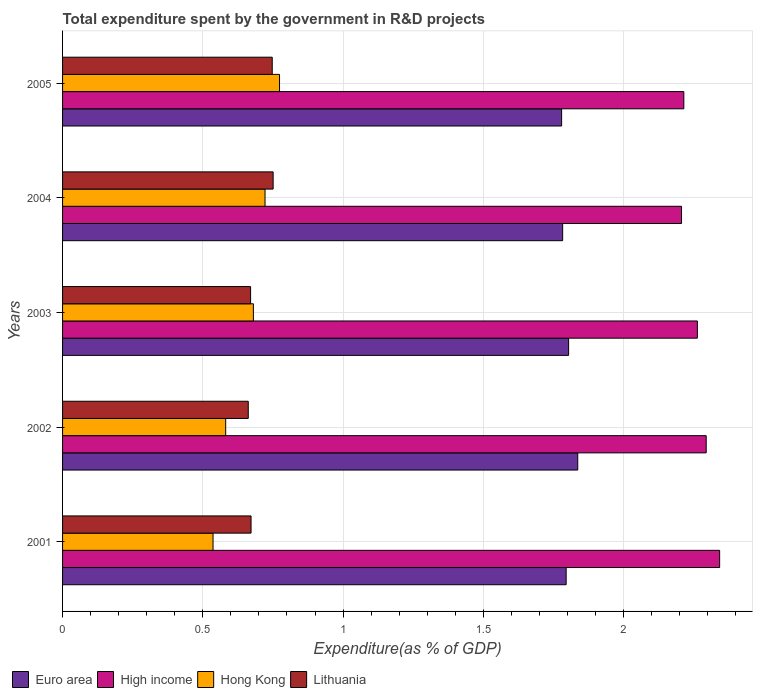How many different coloured bars are there?
Your response must be concise. 4. Are the number of bars per tick equal to the number of legend labels?
Your answer should be compact. Yes. Are the number of bars on each tick of the Y-axis equal?
Offer a very short reply. Yes. What is the total expenditure spent by the government in R&D projects in Hong Kong in 2004?
Provide a short and direct response. 0.72. Across all years, what is the maximum total expenditure spent by the government in R&D projects in Hong Kong?
Your answer should be very brief. 0.77. Across all years, what is the minimum total expenditure spent by the government in R&D projects in High income?
Provide a short and direct response. 2.21. What is the total total expenditure spent by the government in R&D projects in Euro area in the graph?
Provide a short and direct response. 9. What is the difference between the total expenditure spent by the government in R&D projects in Euro area in 2003 and that in 2005?
Keep it short and to the point. 0.02. What is the difference between the total expenditure spent by the government in R&D projects in High income in 2004 and the total expenditure spent by the government in R&D projects in Euro area in 2001?
Offer a very short reply. 0.41. What is the average total expenditure spent by the government in R&D projects in High income per year?
Give a very brief answer. 2.26. In the year 2002, what is the difference between the total expenditure spent by the government in R&D projects in Hong Kong and total expenditure spent by the government in R&D projects in High income?
Your answer should be compact. -1.71. What is the ratio of the total expenditure spent by the government in R&D projects in Hong Kong in 2002 to that in 2005?
Offer a terse response. 0.75. Is the total expenditure spent by the government in R&D projects in Lithuania in 2004 less than that in 2005?
Offer a very short reply. No. What is the difference between the highest and the second highest total expenditure spent by the government in R&D projects in Lithuania?
Ensure brevity in your answer.  0. What is the difference between the highest and the lowest total expenditure spent by the government in R&D projects in Hong Kong?
Ensure brevity in your answer.  0.24. In how many years, is the total expenditure spent by the government in R&D projects in Lithuania greater than the average total expenditure spent by the government in R&D projects in Lithuania taken over all years?
Make the answer very short. 2. Is the sum of the total expenditure spent by the government in R&D projects in Hong Kong in 2002 and 2005 greater than the maximum total expenditure spent by the government in R&D projects in Lithuania across all years?
Provide a succinct answer. Yes. What does the 1st bar from the top in 2004 represents?
Your response must be concise. Lithuania. What does the 1st bar from the bottom in 2005 represents?
Give a very brief answer. Euro area. Is it the case that in every year, the sum of the total expenditure spent by the government in R&D projects in High income and total expenditure spent by the government in R&D projects in Euro area is greater than the total expenditure spent by the government in R&D projects in Hong Kong?
Provide a succinct answer. Yes. Are all the bars in the graph horizontal?
Make the answer very short. Yes. How many years are there in the graph?
Make the answer very short. 5. What is the difference between two consecutive major ticks on the X-axis?
Provide a short and direct response. 0.5. Does the graph contain grids?
Keep it short and to the point. Yes. Where does the legend appear in the graph?
Offer a very short reply. Bottom left. How many legend labels are there?
Provide a short and direct response. 4. How are the legend labels stacked?
Provide a short and direct response. Horizontal. What is the title of the graph?
Your response must be concise. Total expenditure spent by the government in R&D projects. Does "United States" appear as one of the legend labels in the graph?
Provide a succinct answer. No. What is the label or title of the X-axis?
Offer a terse response. Expenditure(as % of GDP). What is the label or title of the Y-axis?
Keep it short and to the point. Years. What is the Expenditure(as % of GDP) in Euro area in 2001?
Your answer should be very brief. 1.8. What is the Expenditure(as % of GDP) in High income in 2001?
Offer a terse response. 2.34. What is the Expenditure(as % of GDP) in Hong Kong in 2001?
Your response must be concise. 0.54. What is the Expenditure(as % of GDP) of Lithuania in 2001?
Give a very brief answer. 0.67. What is the Expenditure(as % of GDP) of Euro area in 2002?
Give a very brief answer. 1.84. What is the Expenditure(as % of GDP) in High income in 2002?
Provide a succinct answer. 2.29. What is the Expenditure(as % of GDP) of Hong Kong in 2002?
Your answer should be very brief. 0.58. What is the Expenditure(as % of GDP) of Lithuania in 2002?
Provide a short and direct response. 0.66. What is the Expenditure(as % of GDP) of Euro area in 2003?
Give a very brief answer. 1.8. What is the Expenditure(as % of GDP) of High income in 2003?
Your response must be concise. 2.26. What is the Expenditure(as % of GDP) of Hong Kong in 2003?
Your answer should be very brief. 0.68. What is the Expenditure(as % of GDP) in Lithuania in 2003?
Offer a terse response. 0.67. What is the Expenditure(as % of GDP) of Euro area in 2004?
Provide a short and direct response. 1.78. What is the Expenditure(as % of GDP) of High income in 2004?
Provide a succinct answer. 2.21. What is the Expenditure(as % of GDP) in Hong Kong in 2004?
Your response must be concise. 0.72. What is the Expenditure(as % of GDP) in Lithuania in 2004?
Offer a very short reply. 0.75. What is the Expenditure(as % of GDP) of Euro area in 2005?
Provide a succinct answer. 1.78. What is the Expenditure(as % of GDP) of High income in 2005?
Offer a very short reply. 2.21. What is the Expenditure(as % of GDP) in Hong Kong in 2005?
Offer a terse response. 0.77. What is the Expenditure(as % of GDP) in Lithuania in 2005?
Your answer should be compact. 0.75. Across all years, what is the maximum Expenditure(as % of GDP) in Euro area?
Provide a succinct answer. 1.84. Across all years, what is the maximum Expenditure(as % of GDP) of High income?
Your answer should be compact. 2.34. Across all years, what is the maximum Expenditure(as % of GDP) of Hong Kong?
Offer a very short reply. 0.77. Across all years, what is the maximum Expenditure(as % of GDP) in Lithuania?
Your response must be concise. 0.75. Across all years, what is the minimum Expenditure(as % of GDP) of Euro area?
Your response must be concise. 1.78. Across all years, what is the minimum Expenditure(as % of GDP) of High income?
Your answer should be compact. 2.21. Across all years, what is the minimum Expenditure(as % of GDP) of Hong Kong?
Offer a very short reply. 0.54. Across all years, what is the minimum Expenditure(as % of GDP) in Lithuania?
Your answer should be very brief. 0.66. What is the total Expenditure(as % of GDP) of Euro area in the graph?
Offer a very short reply. 9. What is the total Expenditure(as % of GDP) in High income in the graph?
Your answer should be very brief. 11.32. What is the total Expenditure(as % of GDP) of Hong Kong in the graph?
Ensure brevity in your answer.  3.29. What is the total Expenditure(as % of GDP) in Lithuania in the graph?
Provide a short and direct response. 3.5. What is the difference between the Expenditure(as % of GDP) of Euro area in 2001 and that in 2002?
Give a very brief answer. -0.04. What is the difference between the Expenditure(as % of GDP) in High income in 2001 and that in 2002?
Keep it short and to the point. 0.05. What is the difference between the Expenditure(as % of GDP) of Hong Kong in 2001 and that in 2002?
Give a very brief answer. -0.04. What is the difference between the Expenditure(as % of GDP) of Lithuania in 2001 and that in 2002?
Provide a short and direct response. 0.01. What is the difference between the Expenditure(as % of GDP) of Euro area in 2001 and that in 2003?
Your answer should be compact. -0.01. What is the difference between the Expenditure(as % of GDP) in High income in 2001 and that in 2003?
Ensure brevity in your answer.  0.08. What is the difference between the Expenditure(as % of GDP) of Hong Kong in 2001 and that in 2003?
Your response must be concise. -0.14. What is the difference between the Expenditure(as % of GDP) of Lithuania in 2001 and that in 2003?
Your answer should be compact. 0. What is the difference between the Expenditure(as % of GDP) of Euro area in 2001 and that in 2004?
Provide a short and direct response. 0.01. What is the difference between the Expenditure(as % of GDP) of High income in 2001 and that in 2004?
Provide a short and direct response. 0.14. What is the difference between the Expenditure(as % of GDP) in Hong Kong in 2001 and that in 2004?
Give a very brief answer. -0.19. What is the difference between the Expenditure(as % of GDP) of Lithuania in 2001 and that in 2004?
Your answer should be compact. -0.08. What is the difference between the Expenditure(as % of GDP) of Euro area in 2001 and that in 2005?
Your answer should be compact. 0.02. What is the difference between the Expenditure(as % of GDP) of High income in 2001 and that in 2005?
Provide a short and direct response. 0.13. What is the difference between the Expenditure(as % of GDP) of Hong Kong in 2001 and that in 2005?
Your answer should be very brief. -0.24. What is the difference between the Expenditure(as % of GDP) of Lithuania in 2001 and that in 2005?
Your answer should be very brief. -0.08. What is the difference between the Expenditure(as % of GDP) of Euro area in 2002 and that in 2003?
Your answer should be very brief. 0.03. What is the difference between the Expenditure(as % of GDP) in High income in 2002 and that in 2003?
Provide a succinct answer. 0.03. What is the difference between the Expenditure(as % of GDP) in Hong Kong in 2002 and that in 2003?
Your answer should be very brief. -0.1. What is the difference between the Expenditure(as % of GDP) of Lithuania in 2002 and that in 2003?
Ensure brevity in your answer.  -0.01. What is the difference between the Expenditure(as % of GDP) of Euro area in 2002 and that in 2004?
Offer a terse response. 0.05. What is the difference between the Expenditure(as % of GDP) of High income in 2002 and that in 2004?
Your answer should be very brief. 0.09. What is the difference between the Expenditure(as % of GDP) in Hong Kong in 2002 and that in 2004?
Ensure brevity in your answer.  -0.14. What is the difference between the Expenditure(as % of GDP) of Lithuania in 2002 and that in 2004?
Make the answer very short. -0.09. What is the difference between the Expenditure(as % of GDP) of Euro area in 2002 and that in 2005?
Your response must be concise. 0.06. What is the difference between the Expenditure(as % of GDP) in High income in 2002 and that in 2005?
Your answer should be compact. 0.08. What is the difference between the Expenditure(as % of GDP) in Hong Kong in 2002 and that in 2005?
Give a very brief answer. -0.19. What is the difference between the Expenditure(as % of GDP) in Lithuania in 2002 and that in 2005?
Provide a short and direct response. -0.09. What is the difference between the Expenditure(as % of GDP) in Euro area in 2003 and that in 2004?
Provide a short and direct response. 0.02. What is the difference between the Expenditure(as % of GDP) of High income in 2003 and that in 2004?
Your answer should be very brief. 0.06. What is the difference between the Expenditure(as % of GDP) of Hong Kong in 2003 and that in 2004?
Your answer should be compact. -0.04. What is the difference between the Expenditure(as % of GDP) of Lithuania in 2003 and that in 2004?
Offer a terse response. -0.08. What is the difference between the Expenditure(as % of GDP) in Euro area in 2003 and that in 2005?
Your response must be concise. 0.02. What is the difference between the Expenditure(as % of GDP) of High income in 2003 and that in 2005?
Offer a very short reply. 0.05. What is the difference between the Expenditure(as % of GDP) in Hong Kong in 2003 and that in 2005?
Offer a terse response. -0.09. What is the difference between the Expenditure(as % of GDP) in Lithuania in 2003 and that in 2005?
Give a very brief answer. -0.08. What is the difference between the Expenditure(as % of GDP) of Euro area in 2004 and that in 2005?
Give a very brief answer. 0. What is the difference between the Expenditure(as % of GDP) in High income in 2004 and that in 2005?
Provide a succinct answer. -0.01. What is the difference between the Expenditure(as % of GDP) of Hong Kong in 2004 and that in 2005?
Offer a terse response. -0.05. What is the difference between the Expenditure(as % of GDP) in Lithuania in 2004 and that in 2005?
Make the answer very short. 0. What is the difference between the Expenditure(as % of GDP) of Euro area in 2001 and the Expenditure(as % of GDP) of High income in 2002?
Your answer should be compact. -0.5. What is the difference between the Expenditure(as % of GDP) in Euro area in 2001 and the Expenditure(as % of GDP) in Hong Kong in 2002?
Keep it short and to the point. 1.21. What is the difference between the Expenditure(as % of GDP) in Euro area in 2001 and the Expenditure(as % of GDP) in Lithuania in 2002?
Ensure brevity in your answer.  1.13. What is the difference between the Expenditure(as % of GDP) in High income in 2001 and the Expenditure(as % of GDP) in Hong Kong in 2002?
Offer a very short reply. 1.76. What is the difference between the Expenditure(as % of GDP) of High income in 2001 and the Expenditure(as % of GDP) of Lithuania in 2002?
Give a very brief answer. 1.68. What is the difference between the Expenditure(as % of GDP) of Hong Kong in 2001 and the Expenditure(as % of GDP) of Lithuania in 2002?
Provide a succinct answer. -0.13. What is the difference between the Expenditure(as % of GDP) of Euro area in 2001 and the Expenditure(as % of GDP) of High income in 2003?
Your answer should be compact. -0.47. What is the difference between the Expenditure(as % of GDP) in Euro area in 2001 and the Expenditure(as % of GDP) in Hong Kong in 2003?
Your answer should be very brief. 1.11. What is the difference between the Expenditure(as % of GDP) of Euro area in 2001 and the Expenditure(as % of GDP) of Lithuania in 2003?
Offer a terse response. 1.12. What is the difference between the Expenditure(as % of GDP) of High income in 2001 and the Expenditure(as % of GDP) of Hong Kong in 2003?
Keep it short and to the point. 1.66. What is the difference between the Expenditure(as % of GDP) in High income in 2001 and the Expenditure(as % of GDP) in Lithuania in 2003?
Your answer should be compact. 1.67. What is the difference between the Expenditure(as % of GDP) in Hong Kong in 2001 and the Expenditure(as % of GDP) in Lithuania in 2003?
Keep it short and to the point. -0.13. What is the difference between the Expenditure(as % of GDP) in Euro area in 2001 and the Expenditure(as % of GDP) in High income in 2004?
Provide a succinct answer. -0.41. What is the difference between the Expenditure(as % of GDP) of Euro area in 2001 and the Expenditure(as % of GDP) of Hong Kong in 2004?
Your answer should be compact. 1.07. What is the difference between the Expenditure(as % of GDP) of Euro area in 2001 and the Expenditure(as % of GDP) of Lithuania in 2004?
Your response must be concise. 1.04. What is the difference between the Expenditure(as % of GDP) in High income in 2001 and the Expenditure(as % of GDP) in Hong Kong in 2004?
Give a very brief answer. 1.62. What is the difference between the Expenditure(as % of GDP) of High income in 2001 and the Expenditure(as % of GDP) of Lithuania in 2004?
Ensure brevity in your answer.  1.59. What is the difference between the Expenditure(as % of GDP) of Hong Kong in 2001 and the Expenditure(as % of GDP) of Lithuania in 2004?
Offer a terse response. -0.21. What is the difference between the Expenditure(as % of GDP) of Euro area in 2001 and the Expenditure(as % of GDP) of High income in 2005?
Keep it short and to the point. -0.42. What is the difference between the Expenditure(as % of GDP) of Euro area in 2001 and the Expenditure(as % of GDP) of Hong Kong in 2005?
Provide a succinct answer. 1.02. What is the difference between the Expenditure(as % of GDP) in Euro area in 2001 and the Expenditure(as % of GDP) in Lithuania in 2005?
Your answer should be compact. 1.05. What is the difference between the Expenditure(as % of GDP) in High income in 2001 and the Expenditure(as % of GDP) in Hong Kong in 2005?
Keep it short and to the point. 1.57. What is the difference between the Expenditure(as % of GDP) of High income in 2001 and the Expenditure(as % of GDP) of Lithuania in 2005?
Your response must be concise. 1.59. What is the difference between the Expenditure(as % of GDP) of Hong Kong in 2001 and the Expenditure(as % of GDP) of Lithuania in 2005?
Offer a terse response. -0.21. What is the difference between the Expenditure(as % of GDP) of Euro area in 2002 and the Expenditure(as % of GDP) of High income in 2003?
Offer a very short reply. -0.43. What is the difference between the Expenditure(as % of GDP) of Euro area in 2002 and the Expenditure(as % of GDP) of Hong Kong in 2003?
Keep it short and to the point. 1.16. What is the difference between the Expenditure(as % of GDP) of Euro area in 2002 and the Expenditure(as % of GDP) of Lithuania in 2003?
Keep it short and to the point. 1.17. What is the difference between the Expenditure(as % of GDP) in High income in 2002 and the Expenditure(as % of GDP) in Hong Kong in 2003?
Provide a succinct answer. 1.61. What is the difference between the Expenditure(as % of GDP) in High income in 2002 and the Expenditure(as % of GDP) in Lithuania in 2003?
Offer a very short reply. 1.62. What is the difference between the Expenditure(as % of GDP) in Hong Kong in 2002 and the Expenditure(as % of GDP) in Lithuania in 2003?
Keep it short and to the point. -0.09. What is the difference between the Expenditure(as % of GDP) of Euro area in 2002 and the Expenditure(as % of GDP) of High income in 2004?
Provide a short and direct response. -0.37. What is the difference between the Expenditure(as % of GDP) of Euro area in 2002 and the Expenditure(as % of GDP) of Hong Kong in 2004?
Your answer should be compact. 1.11. What is the difference between the Expenditure(as % of GDP) of Euro area in 2002 and the Expenditure(as % of GDP) of Lithuania in 2004?
Your response must be concise. 1.09. What is the difference between the Expenditure(as % of GDP) in High income in 2002 and the Expenditure(as % of GDP) in Hong Kong in 2004?
Keep it short and to the point. 1.57. What is the difference between the Expenditure(as % of GDP) in High income in 2002 and the Expenditure(as % of GDP) in Lithuania in 2004?
Offer a very short reply. 1.54. What is the difference between the Expenditure(as % of GDP) of Hong Kong in 2002 and the Expenditure(as % of GDP) of Lithuania in 2004?
Your answer should be compact. -0.17. What is the difference between the Expenditure(as % of GDP) in Euro area in 2002 and the Expenditure(as % of GDP) in High income in 2005?
Make the answer very short. -0.38. What is the difference between the Expenditure(as % of GDP) in Euro area in 2002 and the Expenditure(as % of GDP) in Hong Kong in 2005?
Your answer should be compact. 1.06. What is the difference between the Expenditure(as % of GDP) of Euro area in 2002 and the Expenditure(as % of GDP) of Lithuania in 2005?
Your answer should be compact. 1.09. What is the difference between the Expenditure(as % of GDP) in High income in 2002 and the Expenditure(as % of GDP) in Hong Kong in 2005?
Your response must be concise. 1.52. What is the difference between the Expenditure(as % of GDP) of High income in 2002 and the Expenditure(as % of GDP) of Lithuania in 2005?
Make the answer very short. 1.55. What is the difference between the Expenditure(as % of GDP) in Hong Kong in 2002 and the Expenditure(as % of GDP) in Lithuania in 2005?
Offer a terse response. -0.17. What is the difference between the Expenditure(as % of GDP) of Euro area in 2003 and the Expenditure(as % of GDP) of High income in 2004?
Provide a short and direct response. -0.4. What is the difference between the Expenditure(as % of GDP) of Euro area in 2003 and the Expenditure(as % of GDP) of Hong Kong in 2004?
Provide a short and direct response. 1.08. What is the difference between the Expenditure(as % of GDP) of Euro area in 2003 and the Expenditure(as % of GDP) of Lithuania in 2004?
Provide a short and direct response. 1.05. What is the difference between the Expenditure(as % of GDP) in High income in 2003 and the Expenditure(as % of GDP) in Hong Kong in 2004?
Keep it short and to the point. 1.54. What is the difference between the Expenditure(as % of GDP) in High income in 2003 and the Expenditure(as % of GDP) in Lithuania in 2004?
Provide a short and direct response. 1.51. What is the difference between the Expenditure(as % of GDP) in Hong Kong in 2003 and the Expenditure(as % of GDP) in Lithuania in 2004?
Provide a succinct answer. -0.07. What is the difference between the Expenditure(as % of GDP) of Euro area in 2003 and the Expenditure(as % of GDP) of High income in 2005?
Offer a very short reply. -0.41. What is the difference between the Expenditure(as % of GDP) of Euro area in 2003 and the Expenditure(as % of GDP) of Hong Kong in 2005?
Keep it short and to the point. 1.03. What is the difference between the Expenditure(as % of GDP) in Euro area in 2003 and the Expenditure(as % of GDP) in Lithuania in 2005?
Provide a short and direct response. 1.06. What is the difference between the Expenditure(as % of GDP) in High income in 2003 and the Expenditure(as % of GDP) in Hong Kong in 2005?
Provide a succinct answer. 1.49. What is the difference between the Expenditure(as % of GDP) of High income in 2003 and the Expenditure(as % of GDP) of Lithuania in 2005?
Your answer should be compact. 1.52. What is the difference between the Expenditure(as % of GDP) of Hong Kong in 2003 and the Expenditure(as % of GDP) of Lithuania in 2005?
Give a very brief answer. -0.07. What is the difference between the Expenditure(as % of GDP) in Euro area in 2004 and the Expenditure(as % of GDP) in High income in 2005?
Ensure brevity in your answer.  -0.43. What is the difference between the Expenditure(as % of GDP) in Euro area in 2004 and the Expenditure(as % of GDP) in Hong Kong in 2005?
Ensure brevity in your answer.  1.01. What is the difference between the Expenditure(as % of GDP) of Euro area in 2004 and the Expenditure(as % of GDP) of Lithuania in 2005?
Ensure brevity in your answer.  1.04. What is the difference between the Expenditure(as % of GDP) in High income in 2004 and the Expenditure(as % of GDP) in Hong Kong in 2005?
Keep it short and to the point. 1.43. What is the difference between the Expenditure(as % of GDP) in High income in 2004 and the Expenditure(as % of GDP) in Lithuania in 2005?
Make the answer very short. 1.46. What is the difference between the Expenditure(as % of GDP) of Hong Kong in 2004 and the Expenditure(as % of GDP) of Lithuania in 2005?
Offer a very short reply. -0.03. What is the average Expenditure(as % of GDP) of Euro area per year?
Give a very brief answer. 1.8. What is the average Expenditure(as % of GDP) of High income per year?
Offer a very short reply. 2.26. What is the average Expenditure(as % of GDP) in Hong Kong per year?
Provide a short and direct response. 0.66. What is the average Expenditure(as % of GDP) in Lithuania per year?
Offer a very short reply. 0.7. In the year 2001, what is the difference between the Expenditure(as % of GDP) in Euro area and Expenditure(as % of GDP) in High income?
Make the answer very short. -0.55. In the year 2001, what is the difference between the Expenditure(as % of GDP) of Euro area and Expenditure(as % of GDP) of Hong Kong?
Provide a succinct answer. 1.26. In the year 2001, what is the difference between the Expenditure(as % of GDP) in Euro area and Expenditure(as % of GDP) in Lithuania?
Provide a succinct answer. 1.12. In the year 2001, what is the difference between the Expenditure(as % of GDP) in High income and Expenditure(as % of GDP) in Hong Kong?
Provide a succinct answer. 1.81. In the year 2001, what is the difference between the Expenditure(as % of GDP) of High income and Expenditure(as % of GDP) of Lithuania?
Give a very brief answer. 1.67. In the year 2001, what is the difference between the Expenditure(as % of GDP) in Hong Kong and Expenditure(as % of GDP) in Lithuania?
Your answer should be very brief. -0.14. In the year 2002, what is the difference between the Expenditure(as % of GDP) in Euro area and Expenditure(as % of GDP) in High income?
Make the answer very short. -0.46. In the year 2002, what is the difference between the Expenditure(as % of GDP) in Euro area and Expenditure(as % of GDP) in Hong Kong?
Provide a succinct answer. 1.25. In the year 2002, what is the difference between the Expenditure(as % of GDP) of Euro area and Expenditure(as % of GDP) of Lithuania?
Your answer should be very brief. 1.17. In the year 2002, what is the difference between the Expenditure(as % of GDP) in High income and Expenditure(as % of GDP) in Hong Kong?
Ensure brevity in your answer.  1.71. In the year 2002, what is the difference between the Expenditure(as % of GDP) of High income and Expenditure(as % of GDP) of Lithuania?
Your response must be concise. 1.63. In the year 2002, what is the difference between the Expenditure(as % of GDP) of Hong Kong and Expenditure(as % of GDP) of Lithuania?
Offer a very short reply. -0.08. In the year 2003, what is the difference between the Expenditure(as % of GDP) of Euro area and Expenditure(as % of GDP) of High income?
Your answer should be compact. -0.46. In the year 2003, what is the difference between the Expenditure(as % of GDP) in Euro area and Expenditure(as % of GDP) in Hong Kong?
Your answer should be compact. 1.12. In the year 2003, what is the difference between the Expenditure(as % of GDP) in Euro area and Expenditure(as % of GDP) in Lithuania?
Your answer should be compact. 1.13. In the year 2003, what is the difference between the Expenditure(as % of GDP) in High income and Expenditure(as % of GDP) in Hong Kong?
Provide a succinct answer. 1.58. In the year 2003, what is the difference between the Expenditure(as % of GDP) in High income and Expenditure(as % of GDP) in Lithuania?
Offer a very short reply. 1.59. In the year 2003, what is the difference between the Expenditure(as % of GDP) in Hong Kong and Expenditure(as % of GDP) in Lithuania?
Offer a very short reply. 0.01. In the year 2004, what is the difference between the Expenditure(as % of GDP) in Euro area and Expenditure(as % of GDP) in High income?
Your answer should be compact. -0.42. In the year 2004, what is the difference between the Expenditure(as % of GDP) in Euro area and Expenditure(as % of GDP) in Hong Kong?
Your answer should be compact. 1.06. In the year 2004, what is the difference between the Expenditure(as % of GDP) in Euro area and Expenditure(as % of GDP) in Lithuania?
Provide a short and direct response. 1.03. In the year 2004, what is the difference between the Expenditure(as % of GDP) in High income and Expenditure(as % of GDP) in Hong Kong?
Make the answer very short. 1.48. In the year 2004, what is the difference between the Expenditure(as % of GDP) of High income and Expenditure(as % of GDP) of Lithuania?
Make the answer very short. 1.46. In the year 2004, what is the difference between the Expenditure(as % of GDP) in Hong Kong and Expenditure(as % of GDP) in Lithuania?
Keep it short and to the point. -0.03. In the year 2005, what is the difference between the Expenditure(as % of GDP) of Euro area and Expenditure(as % of GDP) of High income?
Ensure brevity in your answer.  -0.44. In the year 2005, what is the difference between the Expenditure(as % of GDP) of Euro area and Expenditure(as % of GDP) of Hong Kong?
Make the answer very short. 1.01. In the year 2005, what is the difference between the Expenditure(as % of GDP) of Euro area and Expenditure(as % of GDP) of Lithuania?
Offer a very short reply. 1.03. In the year 2005, what is the difference between the Expenditure(as % of GDP) of High income and Expenditure(as % of GDP) of Hong Kong?
Your answer should be very brief. 1.44. In the year 2005, what is the difference between the Expenditure(as % of GDP) in High income and Expenditure(as % of GDP) in Lithuania?
Make the answer very short. 1.47. In the year 2005, what is the difference between the Expenditure(as % of GDP) in Hong Kong and Expenditure(as % of GDP) in Lithuania?
Provide a short and direct response. 0.03. What is the ratio of the Expenditure(as % of GDP) in Euro area in 2001 to that in 2002?
Your answer should be compact. 0.98. What is the ratio of the Expenditure(as % of GDP) of High income in 2001 to that in 2002?
Offer a terse response. 1.02. What is the ratio of the Expenditure(as % of GDP) of Hong Kong in 2001 to that in 2002?
Make the answer very short. 0.92. What is the ratio of the Expenditure(as % of GDP) in Lithuania in 2001 to that in 2002?
Make the answer very short. 1.01. What is the ratio of the Expenditure(as % of GDP) in High income in 2001 to that in 2003?
Your answer should be very brief. 1.04. What is the ratio of the Expenditure(as % of GDP) in Hong Kong in 2001 to that in 2003?
Make the answer very short. 0.79. What is the ratio of the Expenditure(as % of GDP) in Euro area in 2001 to that in 2004?
Offer a very short reply. 1.01. What is the ratio of the Expenditure(as % of GDP) of High income in 2001 to that in 2004?
Make the answer very short. 1.06. What is the ratio of the Expenditure(as % of GDP) of Hong Kong in 2001 to that in 2004?
Provide a short and direct response. 0.74. What is the ratio of the Expenditure(as % of GDP) in Lithuania in 2001 to that in 2004?
Give a very brief answer. 0.9. What is the ratio of the Expenditure(as % of GDP) of Euro area in 2001 to that in 2005?
Your answer should be compact. 1.01. What is the ratio of the Expenditure(as % of GDP) of High income in 2001 to that in 2005?
Offer a terse response. 1.06. What is the ratio of the Expenditure(as % of GDP) in Hong Kong in 2001 to that in 2005?
Ensure brevity in your answer.  0.69. What is the ratio of the Expenditure(as % of GDP) of Lithuania in 2001 to that in 2005?
Offer a terse response. 0.9. What is the ratio of the Expenditure(as % of GDP) in Euro area in 2002 to that in 2003?
Offer a terse response. 1.02. What is the ratio of the Expenditure(as % of GDP) in High income in 2002 to that in 2003?
Provide a short and direct response. 1.01. What is the ratio of the Expenditure(as % of GDP) in Hong Kong in 2002 to that in 2003?
Ensure brevity in your answer.  0.85. What is the ratio of the Expenditure(as % of GDP) in Lithuania in 2002 to that in 2003?
Provide a short and direct response. 0.99. What is the ratio of the Expenditure(as % of GDP) of Euro area in 2002 to that in 2004?
Keep it short and to the point. 1.03. What is the ratio of the Expenditure(as % of GDP) of High income in 2002 to that in 2004?
Make the answer very short. 1.04. What is the ratio of the Expenditure(as % of GDP) of Hong Kong in 2002 to that in 2004?
Ensure brevity in your answer.  0.81. What is the ratio of the Expenditure(as % of GDP) in Lithuania in 2002 to that in 2004?
Your answer should be very brief. 0.88. What is the ratio of the Expenditure(as % of GDP) of Euro area in 2002 to that in 2005?
Provide a short and direct response. 1.03. What is the ratio of the Expenditure(as % of GDP) of High income in 2002 to that in 2005?
Your answer should be compact. 1.04. What is the ratio of the Expenditure(as % of GDP) in Hong Kong in 2002 to that in 2005?
Provide a succinct answer. 0.75. What is the ratio of the Expenditure(as % of GDP) in Lithuania in 2002 to that in 2005?
Keep it short and to the point. 0.89. What is the ratio of the Expenditure(as % of GDP) of Euro area in 2003 to that in 2004?
Give a very brief answer. 1.01. What is the ratio of the Expenditure(as % of GDP) of High income in 2003 to that in 2004?
Offer a terse response. 1.03. What is the ratio of the Expenditure(as % of GDP) of Hong Kong in 2003 to that in 2004?
Keep it short and to the point. 0.94. What is the ratio of the Expenditure(as % of GDP) in Lithuania in 2003 to that in 2004?
Offer a very short reply. 0.89. What is the ratio of the Expenditure(as % of GDP) of Euro area in 2003 to that in 2005?
Provide a short and direct response. 1.01. What is the ratio of the Expenditure(as % of GDP) in High income in 2003 to that in 2005?
Give a very brief answer. 1.02. What is the ratio of the Expenditure(as % of GDP) in Hong Kong in 2003 to that in 2005?
Offer a very short reply. 0.88. What is the ratio of the Expenditure(as % of GDP) in Lithuania in 2003 to that in 2005?
Ensure brevity in your answer.  0.9. What is the ratio of the Expenditure(as % of GDP) of Hong Kong in 2004 to that in 2005?
Ensure brevity in your answer.  0.93. What is the difference between the highest and the second highest Expenditure(as % of GDP) of Euro area?
Your answer should be very brief. 0.03. What is the difference between the highest and the second highest Expenditure(as % of GDP) of High income?
Keep it short and to the point. 0.05. What is the difference between the highest and the second highest Expenditure(as % of GDP) of Hong Kong?
Your answer should be very brief. 0.05. What is the difference between the highest and the second highest Expenditure(as % of GDP) in Lithuania?
Your response must be concise. 0. What is the difference between the highest and the lowest Expenditure(as % of GDP) in Euro area?
Make the answer very short. 0.06. What is the difference between the highest and the lowest Expenditure(as % of GDP) in High income?
Your response must be concise. 0.14. What is the difference between the highest and the lowest Expenditure(as % of GDP) in Hong Kong?
Your response must be concise. 0.24. What is the difference between the highest and the lowest Expenditure(as % of GDP) of Lithuania?
Your response must be concise. 0.09. 